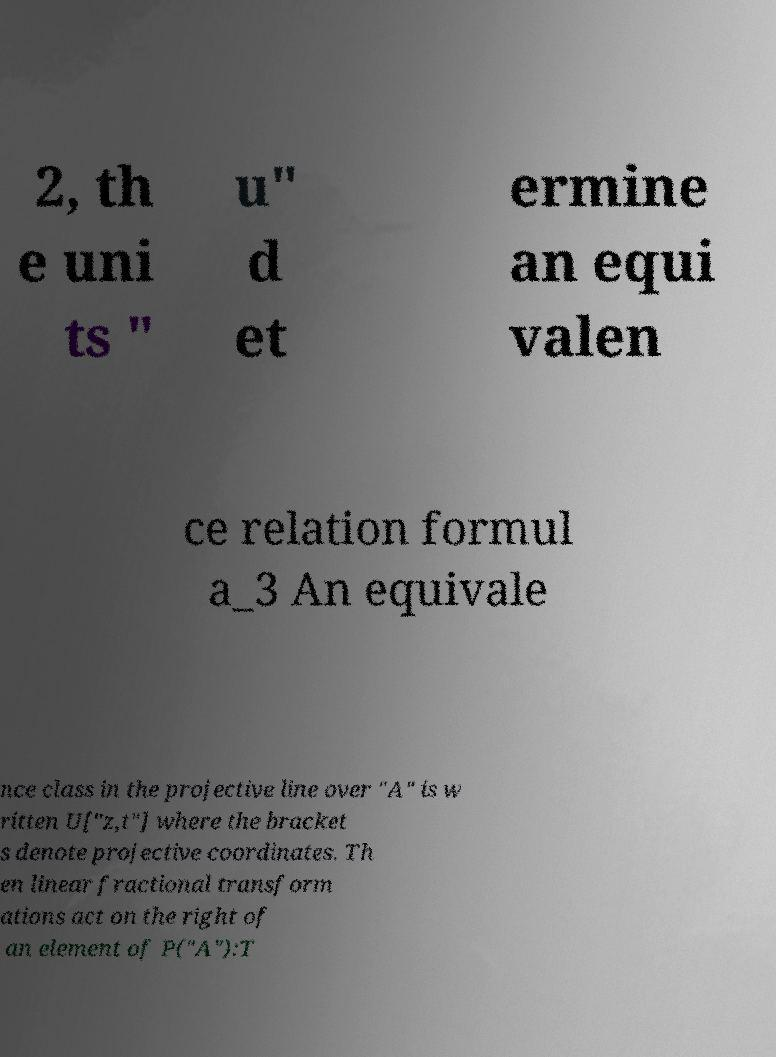Can you read and provide the text displayed in the image?This photo seems to have some interesting text. Can you extract and type it out for me? 2, th e uni ts " u" d et ermine an equi valen ce relation formul a_3 An equivale nce class in the projective line over "A" is w ritten U["z,t"] where the bracket s denote projective coordinates. Th en linear fractional transform ations act on the right of an element of P("A"):T 